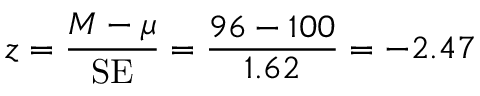Convert formula to latex. <formula><loc_0><loc_0><loc_500><loc_500>z = { \frac { M - \mu } { S E } } = { \frac { 9 6 - 1 0 0 } { 1 . 6 2 } } = - 2 . 4 7 \,</formula> 